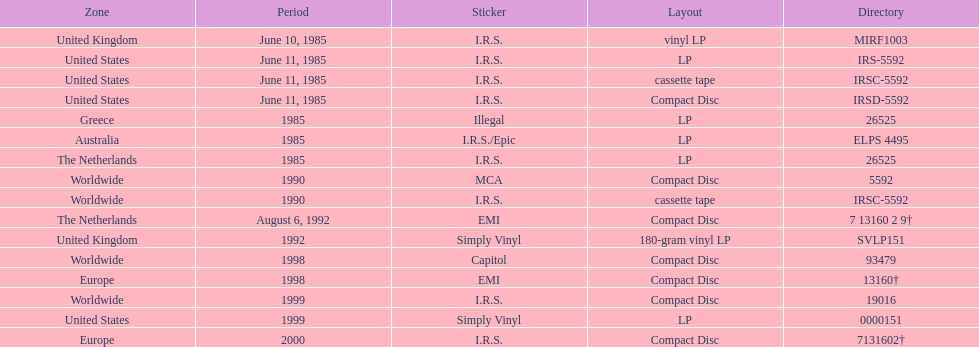Name another region for the 1985 release other than greece. Australia. Could you parse the entire table as a dict? {'header': ['Zone', 'Period', 'Sticker', 'Layout', 'Directory'], 'rows': [['United Kingdom', 'June 10, 1985', 'I.R.S.', 'vinyl LP', 'MIRF1003'], ['United States', 'June 11, 1985', 'I.R.S.', 'LP', 'IRS-5592'], ['United States', 'June 11, 1985', 'I.R.S.', 'cassette tape', 'IRSC-5592'], ['United States', 'June 11, 1985', 'I.R.S.', 'Compact Disc', 'IRSD-5592'], ['Greece', '1985', 'Illegal', 'LP', '26525'], ['Australia', '1985', 'I.R.S./Epic', 'LP', 'ELPS 4495'], ['The Netherlands', '1985', 'I.R.S.', 'LP', '26525'], ['Worldwide', '1990', 'MCA', 'Compact Disc', '5592'], ['Worldwide', '1990', 'I.R.S.', 'cassette tape', 'IRSC-5592'], ['The Netherlands', 'August 6, 1992', 'EMI', 'Compact Disc', '7 13160 2 9†'], ['United Kingdom', '1992', 'Simply Vinyl', '180-gram vinyl LP', 'SVLP151'], ['Worldwide', '1998', 'Capitol', 'Compact Disc', '93479'], ['Europe', '1998', 'EMI', 'Compact Disc', '13160†'], ['Worldwide', '1999', 'I.R.S.', 'Compact Disc', '19016'], ['United States', '1999', 'Simply Vinyl', 'LP', '0000151'], ['Europe', '2000', 'I.R.S.', 'Compact Disc', '7131602†']]} 